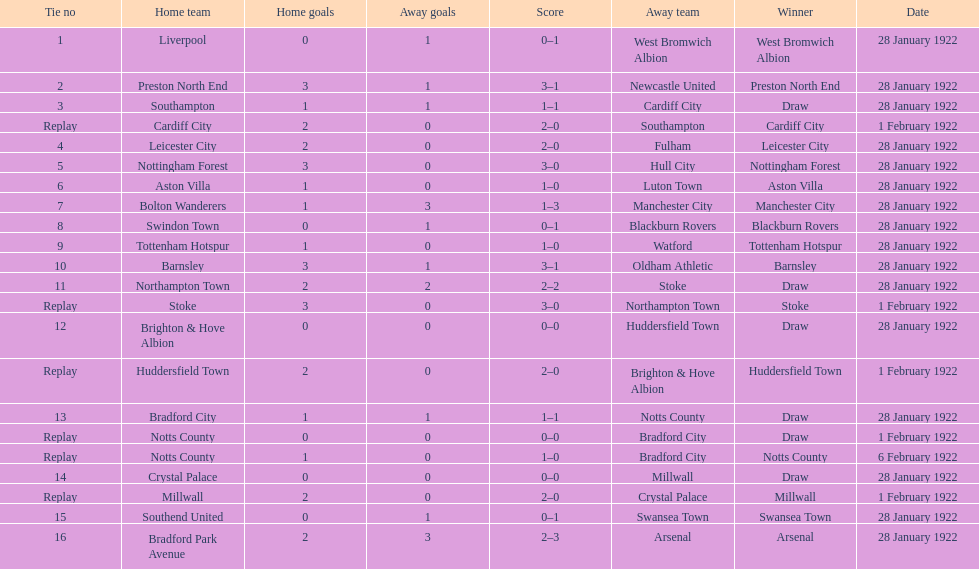Which game had a higher total number of goals scored, 1 or 16? 16. 